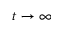<formula> <loc_0><loc_0><loc_500><loc_500>t \to \infty</formula> 